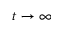<formula> <loc_0><loc_0><loc_500><loc_500>t \to \infty</formula> 